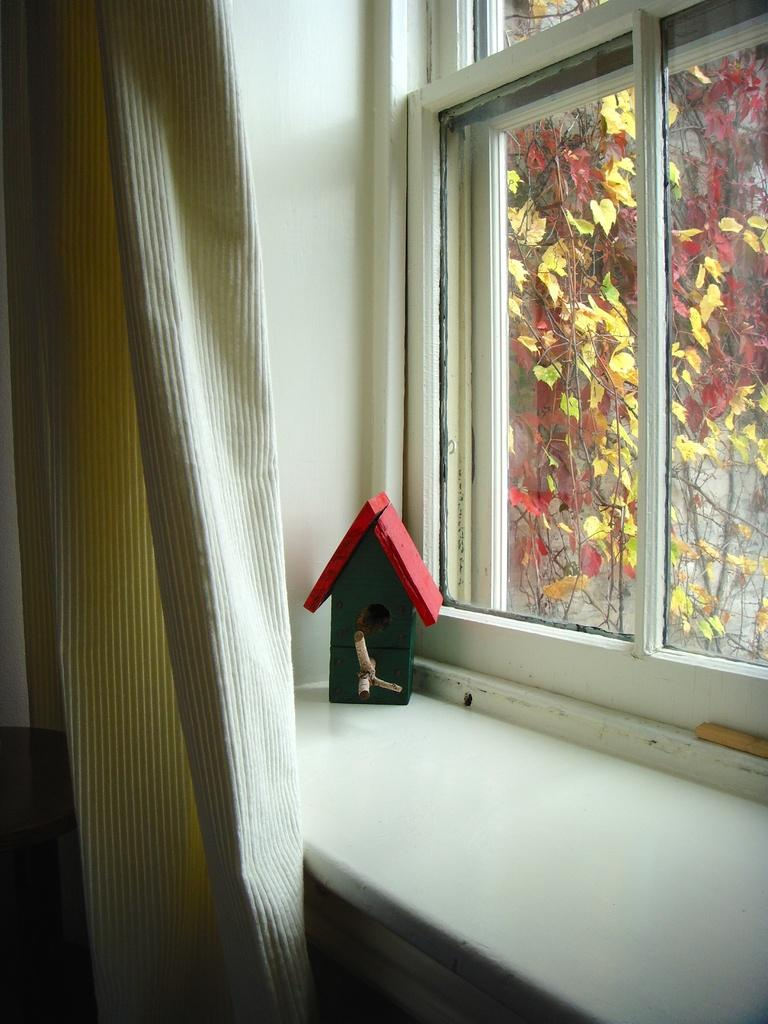What is located on the shelf in the image? There is an object on a shelf in the image, but the specific object is not mentioned in the facts. What type of opening is present in the image? There is a glass window in the image. What can be seen through the glass window? Leaves and stems are visible through the glass window. What else can be seen through the glass window? There is a wall visible through the glass window. Is there any blood visible on the object on the shelf in the image? There is no mention of blood in the image, so we cannot answer this question definitively. Can you see any scissors through the glass window in the image? There is no mention of scissors in the image, so we cannot answer this question definitively. 